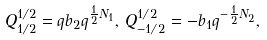Convert formula to latex. <formula><loc_0><loc_0><loc_500><loc_500>Q ^ { 1 / 2 } _ { 1 / 2 } = q b _ { 2 } q ^ { \frac { 1 } { 2 } N _ { 1 } } , \, Q ^ { 1 / 2 } _ { - 1 / 2 } = - b _ { 1 } q ^ { - \frac { 1 } { 2 } N _ { 2 } } ,</formula> 